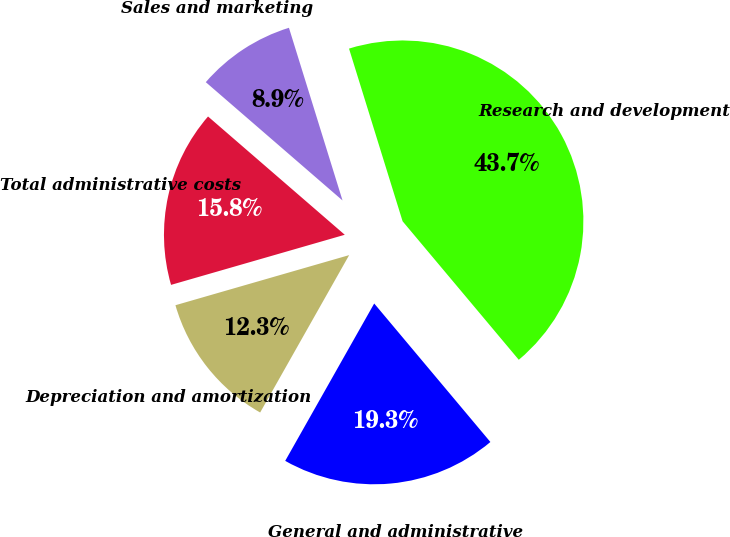Convert chart. <chart><loc_0><loc_0><loc_500><loc_500><pie_chart><fcel>Sales and marketing<fcel>Research and development<fcel>General and administrative<fcel>Depreciation and amortization<fcel>Total administrative costs<nl><fcel>8.86%<fcel>43.68%<fcel>19.3%<fcel>12.34%<fcel>15.82%<nl></chart> 